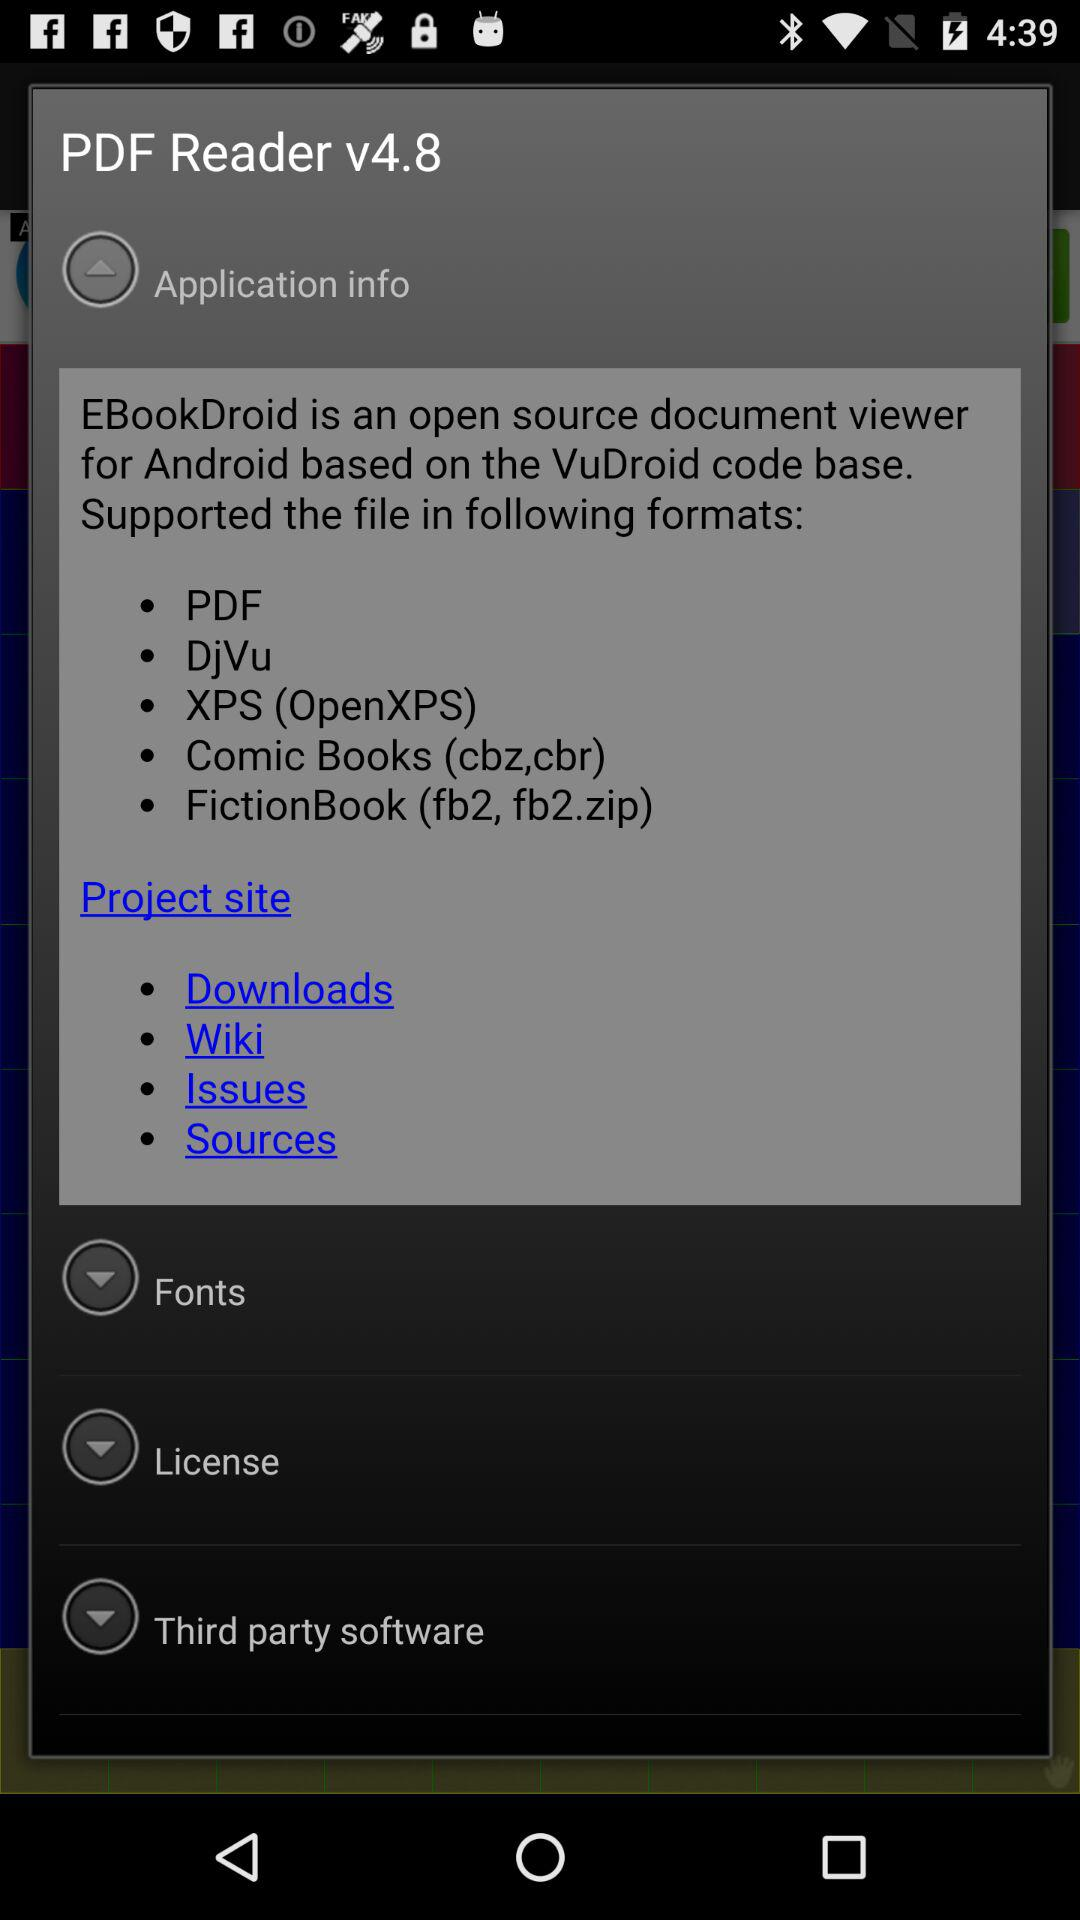What is the version of the "PDF Reader"? The version is 4.8. 